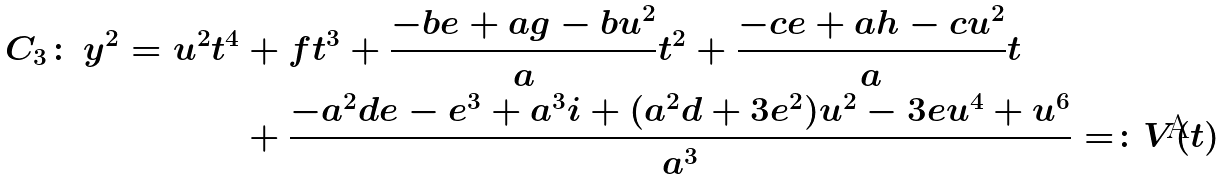Convert formula to latex. <formula><loc_0><loc_0><loc_500><loc_500>C _ { 3 } \colon \, y ^ { 2 } = u ^ { 2 } t ^ { 4 } & + f t ^ { 3 } + \frac { - b e + a g - b u ^ { 2 } } { a } t ^ { 2 } + \frac { - c e + a h - c u ^ { 2 } } { a } t \\ & + \frac { - a ^ { 2 } d e - e ^ { 3 } + a ^ { 3 } i + ( a ^ { 2 } d + 3 e ^ { 2 } ) u ^ { 2 } - 3 e u ^ { 4 } + u ^ { 6 } } { a ^ { 3 } } = \colon V ( t )</formula> 